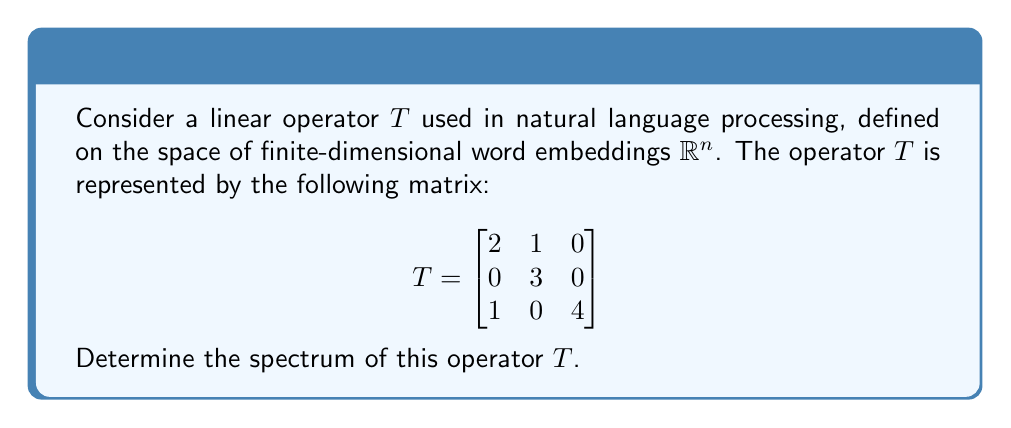Can you answer this question? To determine the spectrum of the linear operator $T$, we need to find all the eigenvalues of the matrix representing $T$. The spectrum of a linear operator is the set of all eigenvalues.

Step 1: Set up the characteristic equation
The characteristic equation is given by $\det(T - \lambda I) = 0$, where $\lambda$ represents the eigenvalues and $I$ is the identity matrix.

$$
\det(T - \lambda I) = \det\begin{bmatrix}
2-\lambda & 1 & 0 \\
0 & 3-\lambda & 0 \\
1 & 0 & 4-\lambda
\end{bmatrix} = 0
$$

Step 2: Expand the determinant
$$(2-\lambda)(3-\lambda)(4-\lambda) - 1 \cdot 1 \cdot 0 = 0$$

Step 3: Simplify the equation
$$(2-\lambda)(3-\lambda)(4-\lambda) = 0$$

Step 4: Solve for $\lambda$
The equation is satisfied when any of the factors is zero:

$2-\lambda = 0 \implies \lambda = 2$
$3-\lambda = 0 \implies \lambda = 3$
$4-\lambda = 0 \implies \lambda = 4$

Therefore, the eigenvalues of $T$ are 2, 3, and 4.

Step 5: Define the spectrum
The spectrum of $T$, denoted as $\sigma(T)$, is the set of all eigenvalues.
Answer: The spectrum of the linear operator $T$ is $\sigma(T) = \{2, 3, 4\}$. 